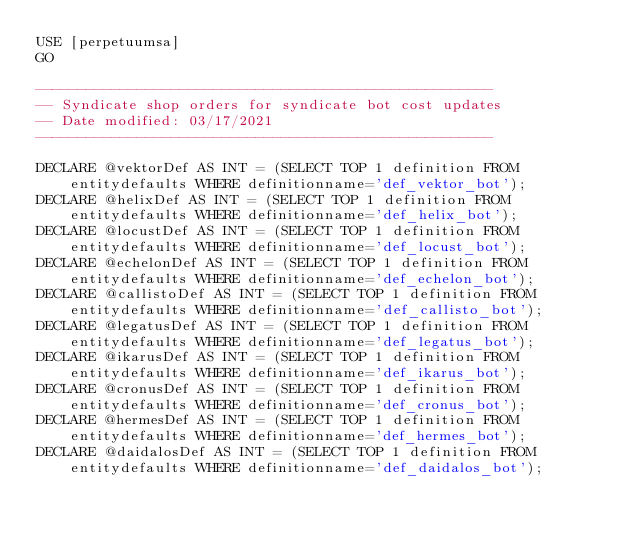<code> <loc_0><loc_0><loc_500><loc_500><_SQL_>USE [perpetuumsa]
GO

------------------------------------------------------
-- Syndicate shop orders for syndicate bot cost updates
-- Date modified: 03/17/2021
------------------------------------------------------

DECLARE @vektorDef AS INT = (SELECT TOP 1 definition FROM entitydefaults WHERE definitionname='def_vektor_bot');
DECLARE @helixDef AS INT = (SELECT TOP 1 definition FROM entitydefaults WHERE definitionname='def_helix_bot');
DECLARE @locustDef AS INT = (SELECT TOP 1 definition FROM entitydefaults WHERE definitionname='def_locust_bot');
DECLARE @echelonDef AS INT = (SELECT TOP 1 definition FROM entitydefaults WHERE definitionname='def_echelon_bot');
DECLARE @callistoDef AS INT = (SELECT TOP 1 definition FROM entitydefaults WHERE definitionname='def_callisto_bot');
DECLARE @legatusDef AS INT = (SELECT TOP 1 definition FROM entitydefaults WHERE definitionname='def_legatus_bot');
DECLARE @ikarusDef AS INT = (SELECT TOP 1 definition FROM entitydefaults WHERE definitionname='def_ikarus_bot');
DECLARE @cronusDef AS INT = (SELECT TOP 1 definition FROM entitydefaults WHERE definitionname='def_cronus_bot');
DECLARE @hermesDef AS INT = (SELECT TOP 1 definition FROM entitydefaults WHERE definitionname='def_hermes_bot');
DECLARE @daidalosDef AS INT = (SELECT TOP 1 definition FROM entitydefaults WHERE definitionname='def_daidalos_bot');</code> 